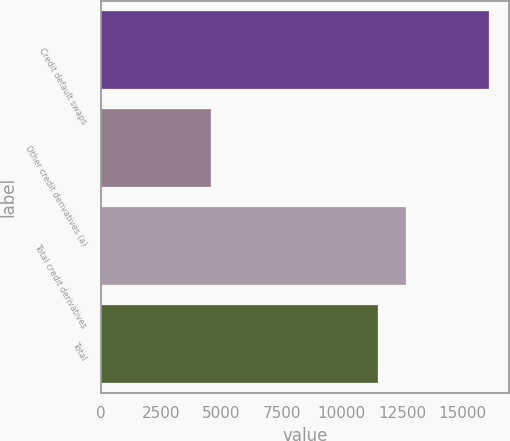Convert chart. <chart><loc_0><loc_0><loc_500><loc_500><bar_chart><fcel>Credit default swaps<fcel>Other credit derivatives (a)<fcel>Total credit derivatives<fcel>Total<nl><fcel>16130<fcel>4580<fcel>12675<fcel>11520<nl></chart> 